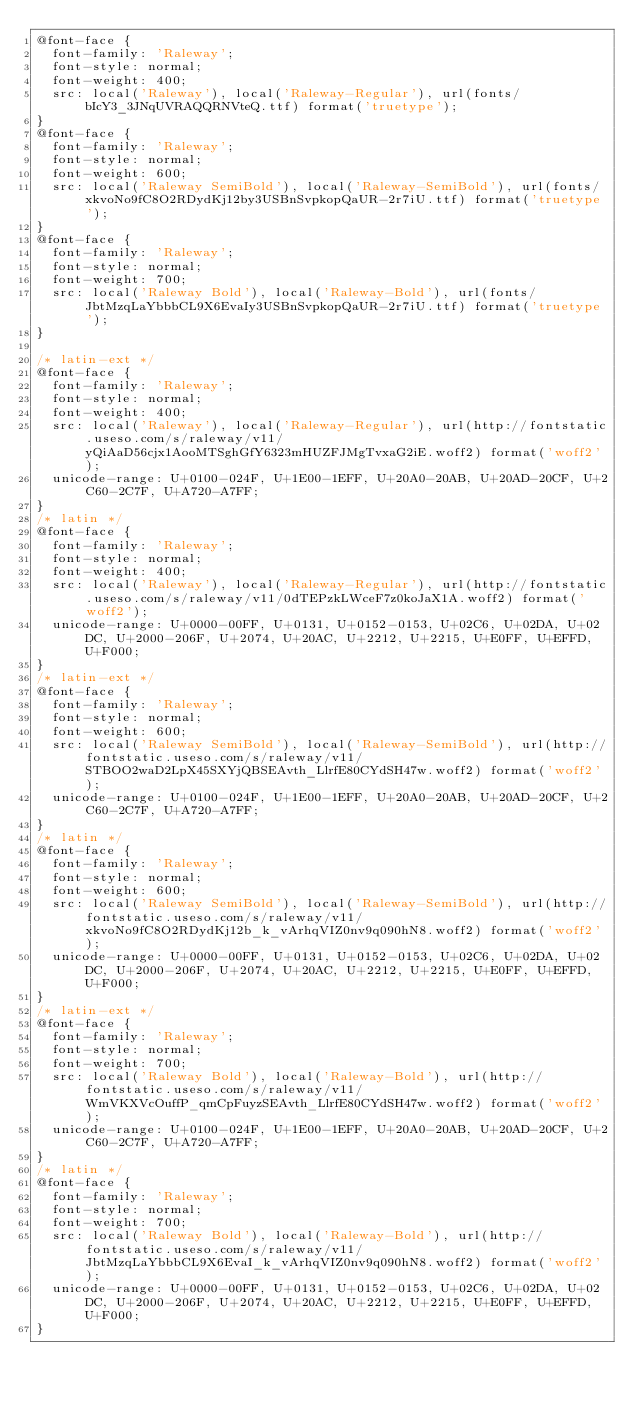Convert code to text. <code><loc_0><loc_0><loc_500><loc_500><_CSS_>@font-face {
  font-family: 'Raleway';
  font-style: normal;
  font-weight: 400;
  src: local('Raleway'), local('Raleway-Regular'), url(fonts/bIcY3_3JNqUVRAQQRNVteQ.ttf) format('truetype');
}
@font-face {
  font-family: 'Raleway';
  font-style: normal;
  font-weight: 600;
  src: local('Raleway SemiBold'), local('Raleway-SemiBold'), url(fonts/xkvoNo9fC8O2RDydKj12by3USBnSvpkopQaUR-2r7iU.ttf) format('truetype');
}
@font-face {
  font-family: 'Raleway';
  font-style: normal;
  font-weight: 700;
  src: local('Raleway Bold'), local('Raleway-Bold'), url(fonts/JbtMzqLaYbbbCL9X6EvaIy3USBnSvpkopQaUR-2r7iU.ttf) format('truetype');
}

/* latin-ext */
@font-face {
  font-family: 'Raleway';
  font-style: normal;
  font-weight: 400;
  src: local('Raleway'), local('Raleway-Regular'), url(http://fontstatic.useso.com/s/raleway/v11/yQiAaD56cjx1AooMTSghGfY6323mHUZFJMgTvxaG2iE.woff2) format('woff2');
  unicode-range: U+0100-024F, U+1E00-1EFF, U+20A0-20AB, U+20AD-20CF, U+2C60-2C7F, U+A720-A7FF;
}
/* latin */
@font-face {
  font-family: 'Raleway';
  font-style: normal;
  font-weight: 400;
  src: local('Raleway'), local('Raleway-Regular'), url(http://fontstatic.useso.com/s/raleway/v11/0dTEPzkLWceF7z0koJaX1A.woff2) format('woff2');
  unicode-range: U+0000-00FF, U+0131, U+0152-0153, U+02C6, U+02DA, U+02DC, U+2000-206F, U+2074, U+20AC, U+2212, U+2215, U+E0FF, U+EFFD, U+F000;
}
/* latin-ext */
@font-face {
  font-family: 'Raleway';
  font-style: normal;
  font-weight: 600;
  src: local('Raleway SemiBold'), local('Raleway-SemiBold'), url(http://fontstatic.useso.com/s/raleway/v11/STBOO2waD2LpX45SXYjQBSEAvth_LlrfE80CYdSH47w.woff2) format('woff2');
  unicode-range: U+0100-024F, U+1E00-1EFF, U+20A0-20AB, U+20AD-20CF, U+2C60-2C7F, U+A720-A7FF;
}
/* latin */
@font-face {
  font-family: 'Raleway';
  font-style: normal;
  font-weight: 600;
  src: local('Raleway SemiBold'), local('Raleway-SemiBold'), url(http://fontstatic.useso.com/s/raleway/v11/xkvoNo9fC8O2RDydKj12b_k_vArhqVIZ0nv9q090hN8.woff2) format('woff2');
  unicode-range: U+0000-00FF, U+0131, U+0152-0153, U+02C6, U+02DA, U+02DC, U+2000-206F, U+2074, U+20AC, U+2212, U+2215, U+E0FF, U+EFFD, U+F000;
}
/* latin-ext */
@font-face {
  font-family: 'Raleway';
  font-style: normal;
  font-weight: 700;
  src: local('Raleway Bold'), local('Raleway-Bold'), url(http://fontstatic.useso.com/s/raleway/v11/WmVKXVcOuffP_qmCpFuyzSEAvth_LlrfE80CYdSH47w.woff2) format('woff2');
  unicode-range: U+0100-024F, U+1E00-1EFF, U+20A0-20AB, U+20AD-20CF, U+2C60-2C7F, U+A720-A7FF;
}
/* latin */
@font-face {
  font-family: 'Raleway';
  font-style: normal;
  font-weight: 700;
  src: local('Raleway Bold'), local('Raleway-Bold'), url(http://fontstatic.useso.com/s/raleway/v11/JbtMzqLaYbbbCL9X6EvaI_k_vArhqVIZ0nv9q090hN8.woff2) format('woff2');
  unicode-range: U+0000-00FF, U+0131, U+0152-0153, U+02C6, U+02DA, U+02DC, U+2000-206F, U+2074, U+20AC, U+2212, U+2215, U+E0FF, U+EFFD, U+F000;
}

</code> 